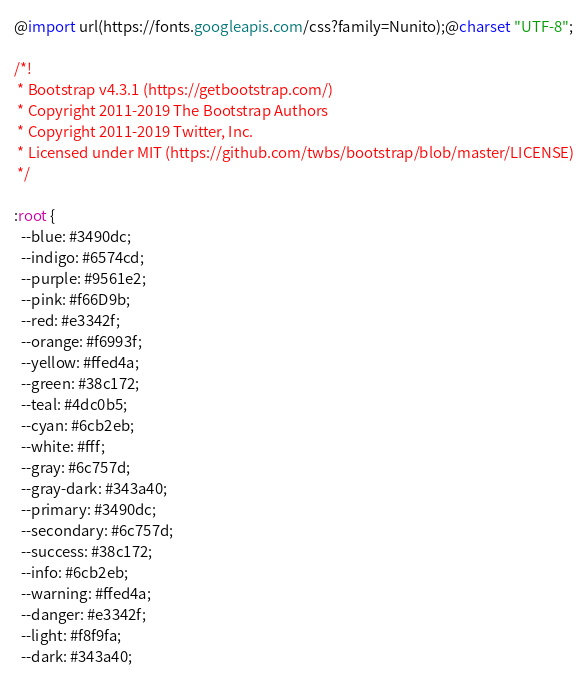Convert code to text. <code><loc_0><loc_0><loc_500><loc_500><_CSS_>@import url(https://fonts.googleapis.com/css?family=Nunito);@charset "UTF-8";

/*!
 * Bootstrap v4.3.1 (https://getbootstrap.com/)
 * Copyright 2011-2019 The Bootstrap Authors
 * Copyright 2011-2019 Twitter, Inc.
 * Licensed under MIT (https://github.com/twbs/bootstrap/blob/master/LICENSE)
 */

:root {
  --blue: #3490dc;
  --indigo: #6574cd;
  --purple: #9561e2;
  --pink: #f66D9b;
  --red: #e3342f;
  --orange: #f6993f;
  --yellow: #ffed4a;
  --green: #38c172;
  --teal: #4dc0b5;
  --cyan: #6cb2eb;
  --white: #fff;
  --gray: #6c757d;
  --gray-dark: #343a40;
  --primary: #3490dc;
  --secondary: #6c757d;
  --success: #38c172;
  --info: #6cb2eb;
  --warning: #ffed4a;
  --danger: #e3342f;
  --light: #f8f9fa;
  --dark: #343a40;</code> 